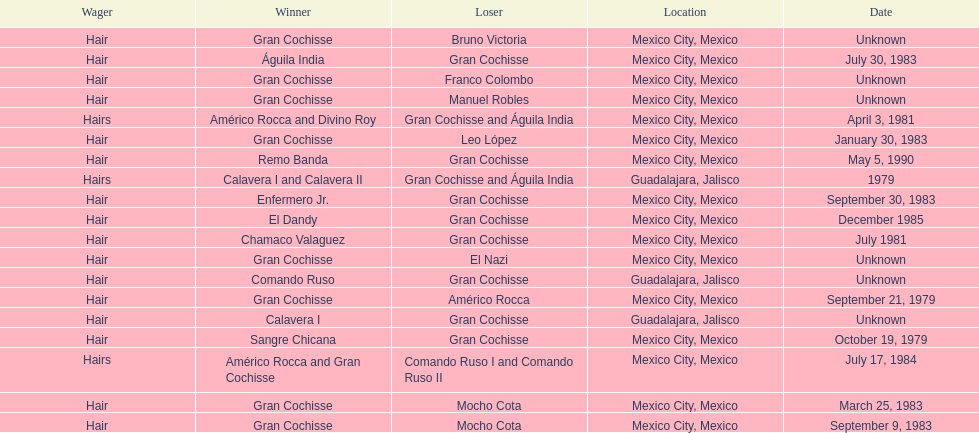How often has the bet been hair? 16. 